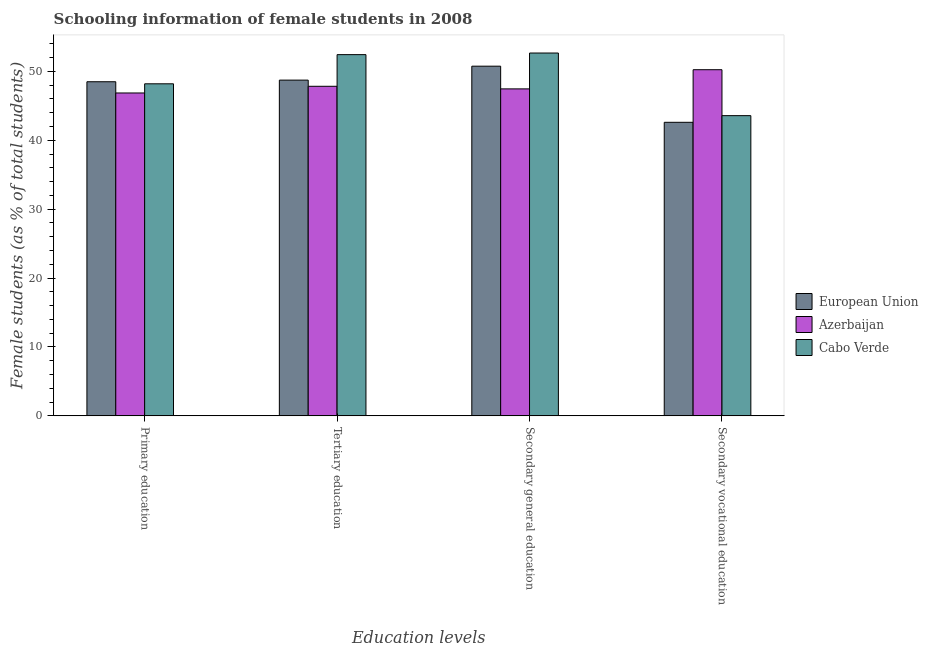How many different coloured bars are there?
Your response must be concise. 3. How many groups of bars are there?
Make the answer very short. 4. Are the number of bars on each tick of the X-axis equal?
Give a very brief answer. Yes. What is the label of the 3rd group of bars from the left?
Give a very brief answer. Secondary general education. What is the percentage of female students in primary education in Azerbaijan?
Provide a short and direct response. 46.87. Across all countries, what is the maximum percentage of female students in primary education?
Your response must be concise. 48.49. Across all countries, what is the minimum percentage of female students in primary education?
Your answer should be very brief. 46.87. What is the total percentage of female students in primary education in the graph?
Your response must be concise. 143.55. What is the difference between the percentage of female students in secondary education in Cabo Verde and that in European Union?
Keep it short and to the point. 1.91. What is the difference between the percentage of female students in secondary vocational education in European Union and the percentage of female students in tertiary education in Cabo Verde?
Keep it short and to the point. -9.82. What is the average percentage of female students in secondary education per country?
Make the answer very short. 50.29. What is the difference between the percentage of female students in secondary education and percentage of female students in primary education in European Union?
Provide a succinct answer. 2.26. In how many countries, is the percentage of female students in secondary vocational education greater than 30 %?
Offer a very short reply. 3. What is the ratio of the percentage of female students in secondary education in Cabo Verde to that in Azerbaijan?
Provide a short and direct response. 1.11. Is the percentage of female students in primary education in Cabo Verde less than that in Azerbaijan?
Offer a very short reply. No. What is the difference between the highest and the second highest percentage of female students in primary education?
Provide a succinct answer. 0.3. What is the difference between the highest and the lowest percentage of female students in primary education?
Provide a short and direct response. 1.63. Is it the case that in every country, the sum of the percentage of female students in tertiary education and percentage of female students in primary education is greater than the sum of percentage of female students in secondary education and percentage of female students in secondary vocational education?
Provide a short and direct response. No. What does the 2nd bar from the left in Primary education represents?
Your answer should be very brief. Azerbaijan. What does the 2nd bar from the right in Secondary vocational education represents?
Your answer should be compact. Azerbaijan. How many bars are there?
Offer a terse response. 12. What is the difference between two consecutive major ticks on the Y-axis?
Keep it short and to the point. 10. How are the legend labels stacked?
Offer a very short reply. Vertical. What is the title of the graph?
Give a very brief answer. Schooling information of female students in 2008. Does "Iceland" appear as one of the legend labels in the graph?
Ensure brevity in your answer.  No. What is the label or title of the X-axis?
Provide a succinct answer. Education levels. What is the label or title of the Y-axis?
Provide a short and direct response. Female students (as % of total students). What is the Female students (as % of total students) of European Union in Primary education?
Keep it short and to the point. 48.49. What is the Female students (as % of total students) of Azerbaijan in Primary education?
Ensure brevity in your answer.  46.87. What is the Female students (as % of total students) in Cabo Verde in Primary education?
Your answer should be compact. 48.2. What is the Female students (as % of total students) of European Union in Tertiary education?
Provide a short and direct response. 48.73. What is the Female students (as % of total students) of Azerbaijan in Tertiary education?
Offer a terse response. 47.83. What is the Female students (as % of total students) of Cabo Verde in Tertiary education?
Make the answer very short. 52.43. What is the Female students (as % of total students) of European Union in Secondary general education?
Your answer should be very brief. 50.75. What is the Female students (as % of total students) in Azerbaijan in Secondary general education?
Make the answer very short. 47.46. What is the Female students (as % of total students) of Cabo Verde in Secondary general education?
Offer a terse response. 52.66. What is the Female students (as % of total students) in European Union in Secondary vocational education?
Your answer should be compact. 42.61. What is the Female students (as % of total students) of Azerbaijan in Secondary vocational education?
Your response must be concise. 50.24. What is the Female students (as % of total students) in Cabo Verde in Secondary vocational education?
Offer a very short reply. 43.57. Across all Education levels, what is the maximum Female students (as % of total students) in European Union?
Offer a terse response. 50.75. Across all Education levels, what is the maximum Female students (as % of total students) of Azerbaijan?
Provide a succinct answer. 50.24. Across all Education levels, what is the maximum Female students (as % of total students) in Cabo Verde?
Ensure brevity in your answer.  52.66. Across all Education levels, what is the minimum Female students (as % of total students) of European Union?
Your answer should be compact. 42.61. Across all Education levels, what is the minimum Female students (as % of total students) of Azerbaijan?
Your answer should be very brief. 46.87. Across all Education levels, what is the minimum Female students (as % of total students) in Cabo Verde?
Your answer should be very brief. 43.57. What is the total Female students (as % of total students) of European Union in the graph?
Offer a very short reply. 190.59. What is the total Female students (as % of total students) in Azerbaijan in the graph?
Your answer should be very brief. 192.4. What is the total Female students (as % of total students) of Cabo Verde in the graph?
Your answer should be compact. 196.86. What is the difference between the Female students (as % of total students) of European Union in Primary education and that in Tertiary education?
Provide a succinct answer. -0.24. What is the difference between the Female students (as % of total students) of Azerbaijan in Primary education and that in Tertiary education?
Provide a short and direct response. -0.97. What is the difference between the Female students (as % of total students) of Cabo Verde in Primary education and that in Tertiary education?
Keep it short and to the point. -4.23. What is the difference between the Female students (as % of total students) in European Union in Primary education and that in Secondary general education?
Keep it short and to the point. -2.26. What is the difference between the Female students (as % of total students) in Azerbaijan in Primary education and that in Secondary general education?
Offer a terse response. -0.59. What is the difference between the Female students (as % of total students) in Cabo Verde in Primary education and that in Secondary general education?
Ensure brevity in your answer.  -4.47. What is the difference between the Female students (as % of total students) in European Union in Primary education and that in Secondary vocational education?
Keep it short and to the point. 5.89. What is the difference between the Female students (as % of total students) in Azerbaijan in Primary education and that in Secondary vocational education?
Offer a terse response. -3.37. What is the difference between the Female students (as % of total students) in Cabo Verde in Primary education and that in Secondary vocational education?
Keep it short and to the point. 4.62. What is the difference between the Female students (as % of total students) in European Union in Tertiary education and that in Secondary general education?
Provide a succinct answer. -2.02. What is the difference between the Female students (as % of total students) in Azerbaijan in Tertiary education and that in Secondary general education?
Your answer should be compact. 0.38. What is the difference between the Female students (as % of total students) of Cabo Verde in Tertiary education and that in Secondary general education?
Make the answer very short. -0.23. What is the difference between the Female students (as % of total students) of European Union in Tertiary education and that in Secondary vocational education?
Provide a short and direct response. 6.12. What is the difference between the Female students (as % of total students) in Azerbaijan in Tertiary education and that in Secondary vocational education?
Give a very brief answer. -2.41. What is the difference between the Female students (as % of total students) of Cabo Verde in Tertiary education and that in Secondary vocational education?
Provide a succinct answer. 8.86. What is the difference between the Female students (as % of total students) of European Union in Secondary general education and that in Secondary vocational education?
Ensure brevity in your answer.  8.15. What is the difference between the Female students (as % of total students) in Azerbaijan in Secondary general education and that in Secondary vocational education?
Offer a terse response. -2.78. What is the difference between the Female students (as % of total students) of Cabo Verde in Secondary general education and that in Secondary vocational education?
Provide a succinct answer. 9.09. What is the difference between the Female students (as % of total students) in European Union in Primary education and the Female students (as % of total students) in Azerbaijan in Tertiary education?
Your response must be concise. 0.66. What is the difference between the Female students (as % of total students) in European Union in Primary education and the Female students (as % of total students) in Cabo Verde in Tertiary education?
Provide a short and direct response. -3.94. What is the difference between the Female students (as % of total students) in Azerbaijan in Primary education and the Female students (as % of total students) in Cabo Verde in Tertiary education?
Keep it short and to the point. -5.56. What is the difference between the Female students (as % of total students) of European Union in Primary education and the Female students (as % of total students) of Azerbaijan in Secondary general education?
Offer a very short reply. 1.04. What is the difference between the Female students (as % of total students) of European Union in Primary education and the Female students (as % of total students) of Cabo Verde in Secondary general education?
Keep it short and to the point. -4.17. What is the difference between the Female students (as % of total students) in Azerbaijan in Primary education and the Female students (as % of total students) in Cabo Verde in Secondary general education?
Offer a terse response. -5.8. What is the difference between the Female students (as % of total students) of European Union in Primary education and the Female students (as % of total students) of Azerbaijan in Secondary vocational education?
Offer a very short reply. -1.75. What is the difference between the Female students (as % of total students) in European Union in Primary education and the Female students (as % of total students) in Cabo Verde in Secondary vocational education?
Your answer should be compact. 4.92. What is the difference between the Female students (as % of total students) of Azerbaijan in Primary education and the Female students (as % of total students) of Cabo Verde in Secondary vocational education?
Make the answer very short. 3.29. What is the difference between the Female students (as % of total students) in European Union in Tertiary education and the Female students (as % of total students) in Azerbaijan in Secondary general education?
Provide a short and direct response. 1.27. What is the difference between the Female students (as % of total students) in European Union in Tertiary education and the Female students (as % of total students) in Cabo Verde in Secondary general education?
Provide a succinct answer. -3.93. What is the difference between the Female students (as % of total students) in Azerbaijan in Tertiary education and the Female students (as % of total students) in Cabo Verde in Secondary general education?
Offer a very short reply. -4.83. What is the difference between the Female students (as % of total students) of European Union in Tertiary education and the Female students (as % of total students) of Azerbaijan in Secondary vocational education?
Provide a succinct answer. -1.51. What is the difference between the Female students (as % of total students) in European Union in Tertiary education and the Female students (as % of total students) in Cabo Verde in Secondary vocational education?
Keep it short and to the point. 5.16. What is the difference between the Female students (as % of total students) in Azerbaijan in Tertiary education and the Female students (as % of total students) in Cabo Verde in Secondary vocational education?
Ensure brevity in your answer.  4.26. What is the difference between the Female students (as % of total students) in European Union in Secondary general education and the Female students (as % of total students) in Azerbaijan in Secondary vocational education?
Your answer should be compact. 0.51. What is the difference between the Female students (as % of total students) of European Union in Secondary general education and the Female students (as % of total students) of Cabo Verde in Secondary vocational education?
Provide a succinct answer. 7.18. What is the difference between the Female students (as % of total students) in Azerbaijan in Secondary general education and the Female students (as % of total students) in Cabo Verde in Secondary vocational education?
Provide a short and direct response. 3.88. What is the average Female students (as % of total students) in European Union per Education levels?
Make the answer very short. 47.65. What is the average Female students (as % of total students) of Azerbaijan per Education levels?
Your answer should be compact. 48.1. What is the average Female students (as % of total students) in Cabo Verde per Education levels?
Ensure brevity in your answer.  49.22. What is the difference between the Female students (as % of total students) in European Union and Female students (as % of total students) in Azerbaijan in Primary education?
Provide a short and direct response. 1.63. What is the difference between the Female students (as % of total students) of European Union and Female students (as % of total students) of Cabo Verde in Primary education?
Your answer should be compact. 0.3. What is the difference between the Female students (as % of total students) in Azerbaijan and Female students (as % of total students) in Cabo Verde in Primary education?
Keep it short and to the point. -1.33. What is the difference between the Female students (as % of total students) in European Union and Female students (as % of total students) in Azerbaijan in Tertiary education?
Give a very brief answer. 0.9. What is the difference between the Female students (as % of total students) of European Union and Female students (as % of total students) of Cabo Verde in Tertiary education?
Your answer should be compact. -3.7. What is the difference between the Female students (as % of total students) in Azerbaijan and Female students (as % of total students) in Cabo Verde in Tertiary education?
Your response must be concise. -4.6. What is the difference between the Female students (as % of total students) in European Union and Female students (as % of total students) in Azerbaijan in Secondary general education?
Your answer should be compact. 3.3. What is the difference between the Female students (as % of total students) in European Union and Female students (as % of total students) in Cabo Verde in Secondary general education?
Ensure brevity in your answer.  -1.91. What is the difference between the Female students (as % of total students) of Azerbaijan and Female students (as % of total students) of Cabo Verde in Secondary general education?
Make the answer very short. -5.21. What is the difference between the Female students (as % of total students) of European Union and Female students (as % of total students) of Azerbaijan in Secondary vocational education?
Offer a terse response. -7.63. What is the difference between the Female students (as % of total students) in European Union and Female students (as % of total students) in Cabo Verde in Secondary vocational education?
Ensure brevity in your answer.  -0.97. What is the difference between the Female students (as % of total students) in Azerbaijan and Female students (as % of total students) in Cabo Verde in Secondary vocational education?
Provide a short and direct response. 6.67. What is the ratio of the Female students (as % of total students) of Azerbaijan in Primary education to that in Tertiary education?
Provide a short and direct response. 0.98. What is the ratio of the Female students (as % of total students) in Cabo Verde in Primary education to that in Tertiary education?
Ensure brevity in your answer.  0.92. What is the ratio of the Female students (as % of total students) of European Union in Primary education to that in Secondary general education?
Keep it short and to the point. 0.96. What is the ratio of the Female students (as % of total students) of Azerbaijan in Primary education to that in Secondary general education?
Keep it short and to the point. 0.99. What is the ratio of the Female students (as % of total students) in Cabo Verde in Primary education to that in Secondary general education?
Provide a succinct answer. 0.92. What is the ratio of the Female students (as % of total students) in European Union in Primary education to that in Secondary vocational education?
Make the answer very short. 1.14. What is the ratio of the Female students (as % of total students) of Azerbaijan in Primary education to that in Secondary vocational education?
Provide a short and direct response. 0.93. What is the ratio of the Female students (as % of total students) of Cabo Verde in Primary education to that in Secondary vocational education?
Offer a very short reply. 1.11. What is the ratio of the Female students (as % of total students) of European Union in Tertiary education to that in Secondary general education?
Your response must be concise. 0.96. What is the ratio of the Female students (as % of total students) in Azerbaijan in Tertiary education to that in Secondary general education?
Provide a succinct answer. 1.01. What is the ratio of the Female students (as % of total students) of European Union in Tertiary education to that in Secondary vocational education?
Ensure brevity in your answer.  1.14. What is the ratio of the Female students (as % of total students) in Azerbaijan in Tertiary education to that in Secondary vocational education?
Provide a succinct answer. 0.95. What is the ratio of the Female students (as % of total students) of Cabo Verde in Tertiary education to that in Secondary vocational education?
Your response must be concise. 1.2. What is the ratio of the Female students (as % of total students) in European Union in Secondary general education to that in Secondary vocational education?
Give a very brief answer. 1.19. What is the ratio of the Female students (as % of total students) in Azerbaijan in Secondary general education to that in Secondary vocational education?
Your response must be concise. 0.94. What is the ratio of the Female students (as % of total students) in Cabo Verde in Secondary general education to that in Secondary vocational education?
Your answer should be very brief. 1.21. What is the difference between the highest and the second highest Female students (as % of total students) in European Union?
Provide a short and direct response. 2.02. What is the difference between the highest and the second highest Female students (as % of total students) in Azerbaijan?
Your answer should be very brief. 2.41. What is the difference between the highest and the second highest Female students (as % of total students) of Cabo Verde?
Give a very brief answer. 0.23. What is the difference between the highest and the lowest Female students (as % of total students) of European Union?
Keep it short and to the point. 8.15. What is the difference between the highest and the lowest Female students (as % of total students) in Azerbaijan?
Your answer should be very brief. 3.37. What is the difference between the highest and the lowest Female students (as % of total students) of Cabo Verde?
Make the answer very short. 9.09. 